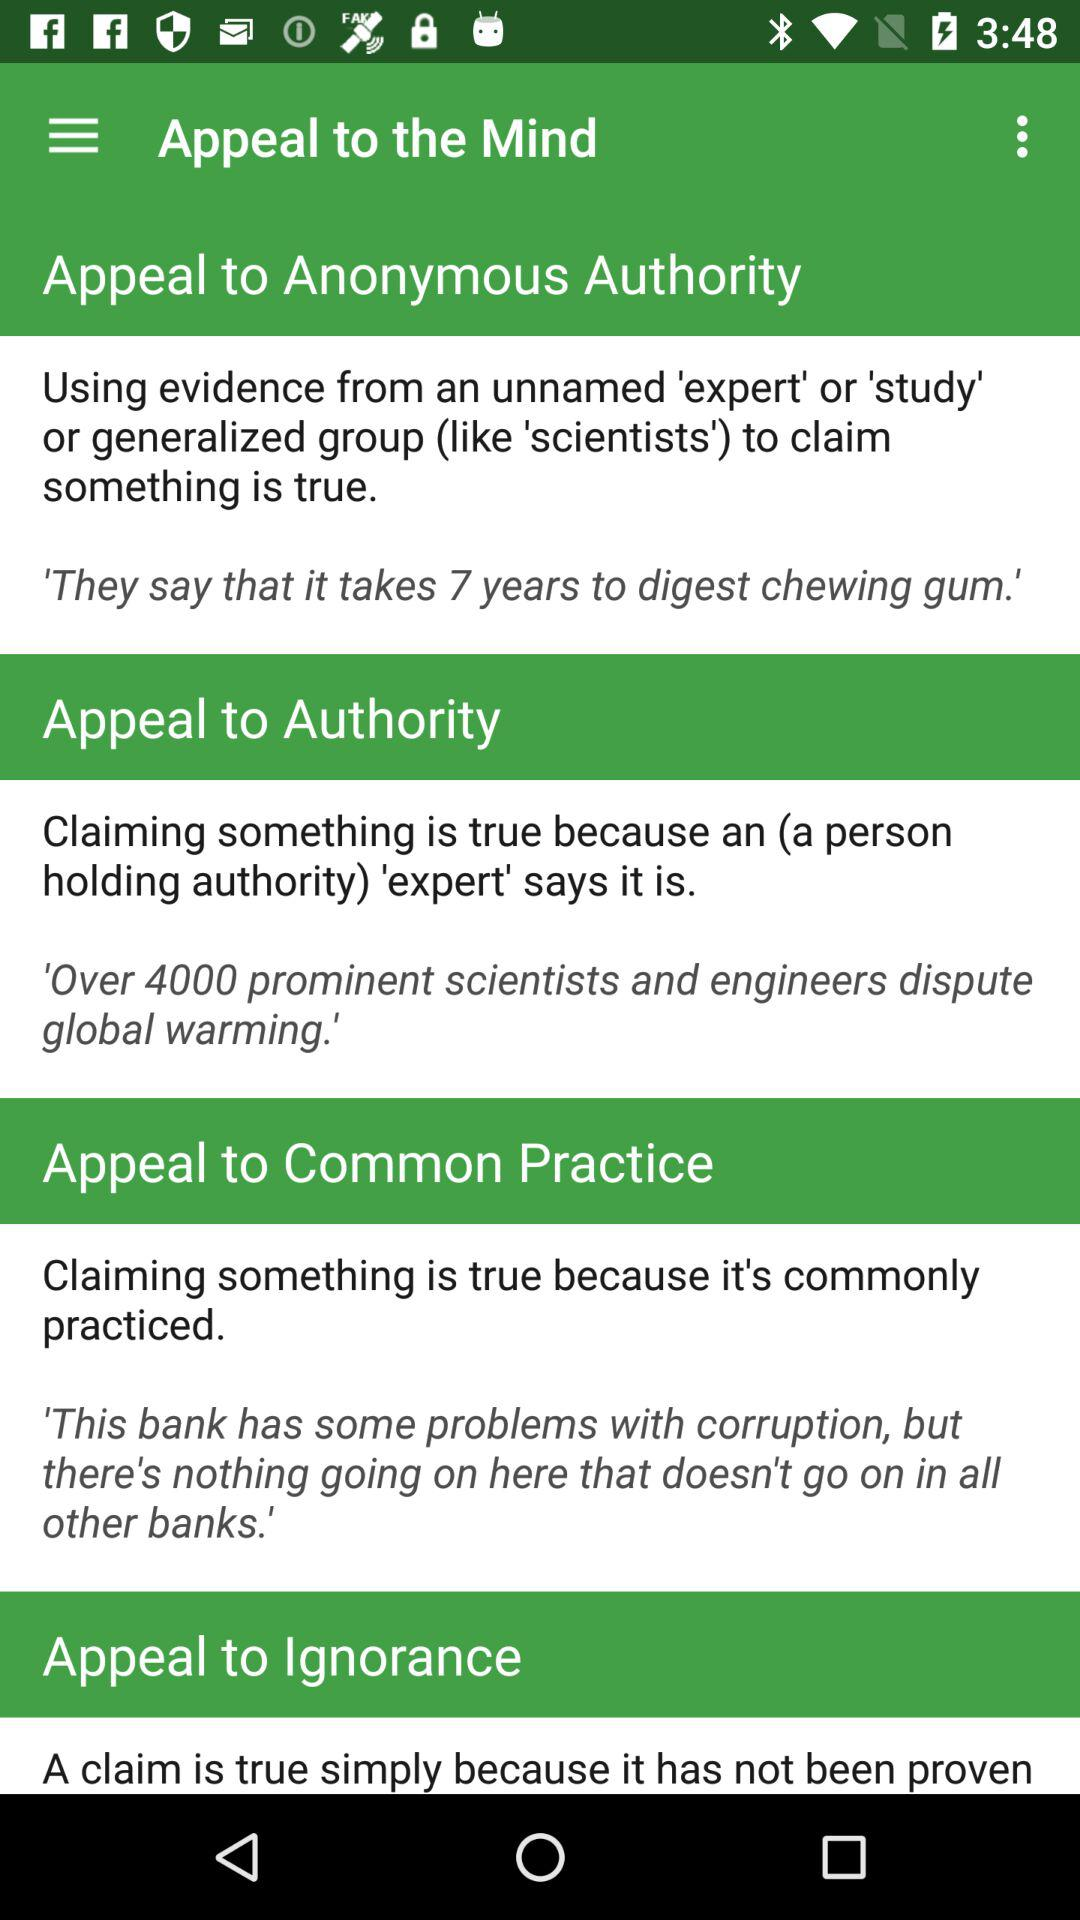How many years does it take to digest chewing gum? It takes 7 years to digest chewing gum. 